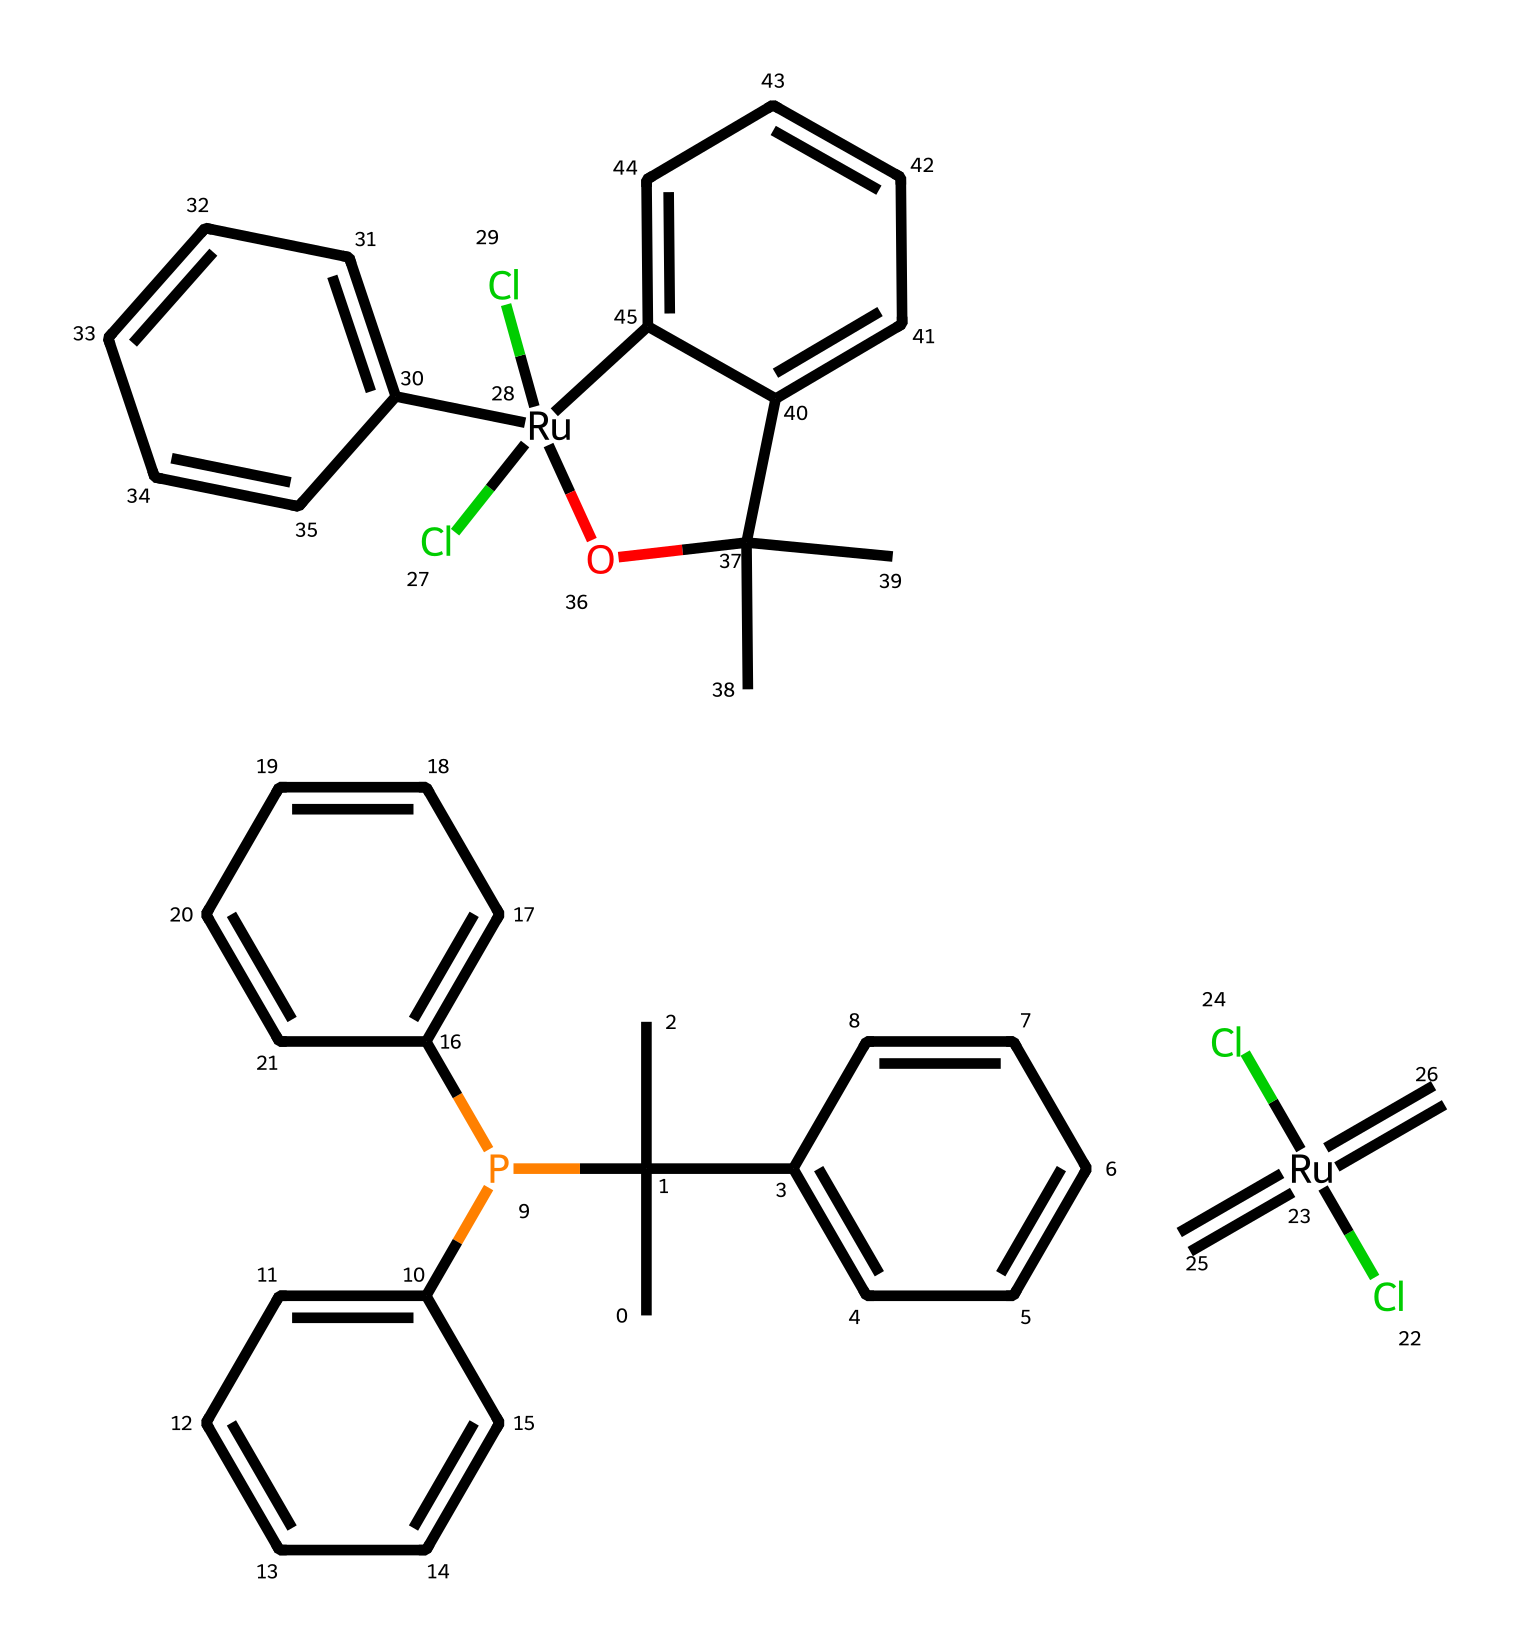What is the central metal in this compound? The structure shows two instances of "Ru" which represents ruthenium, indicating it is the central metal in the Grubbs catalyst.
Answer: ruthenium How many chlorine atoms are present in this chemical? By analyzing the SMILES representation, there are four instances of "Cl", indicating the presence of four chlorine atoms in the compound.
Answer: four What type of bonding is present between the carbon and ruthenium? The presence of the "=" symbol indicates a double bond between carbon and ruthenium, representing the metal-carbon interaction characteristic of organometallic compounds.
Answer: double Count the number of aromatic rings in the compound. The structure contains multiple "C" connected in a cyclic, planar arrangement, indicating aromaticity. There are five distinct aromatic rings in total.
Answer: five What is the oxidation state of ruthenium in this catalyst? The structure shows ruthenium bonded to chlorine and carbon in a way that suggests it has a +2 oxidation state, as indicated by the coupling with the anionic groups (chlorine).
Answer: +2 Are there any phosphorus atoms in this structure? The presence of "P" signifies there is one phosphorus atom within the structure of the Grubbs catalyst.
Answer: one 